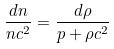Convert formula to latex. <formula><loc_0><loc_0><loc_500><loc_500>\frac { d n } { n c ^ { 2 } } = \frac { d \rho } { p + \rho c ^ { 2 } }</formula> 